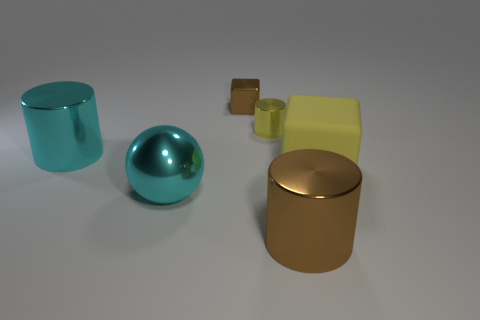Add 3 large cyan metallic balls. How many objects exist? 9 Subtract all spheres. How many objects are left? 5 Add 5 metal balls. How many metal balls exist? 6 Subtract 0 green spheres. How many objects are left? 6 Subtract all metallic blocks. Subtract all big cyan balls. How many objects are left? 4 Add 2 cylinders. How many cylinders are left? 5 